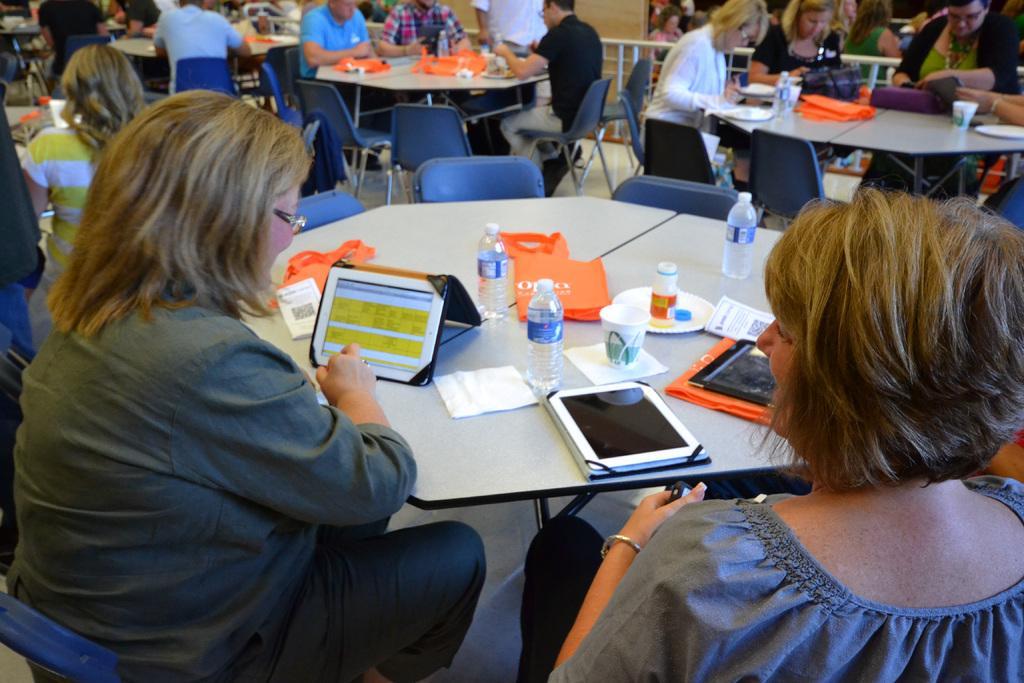In one or two sentences, can you explain what this image depicts? In this picture, group of people are sat on the chairs. There are few tables, few items are placed on it. At the top of the image, we can see rods. 